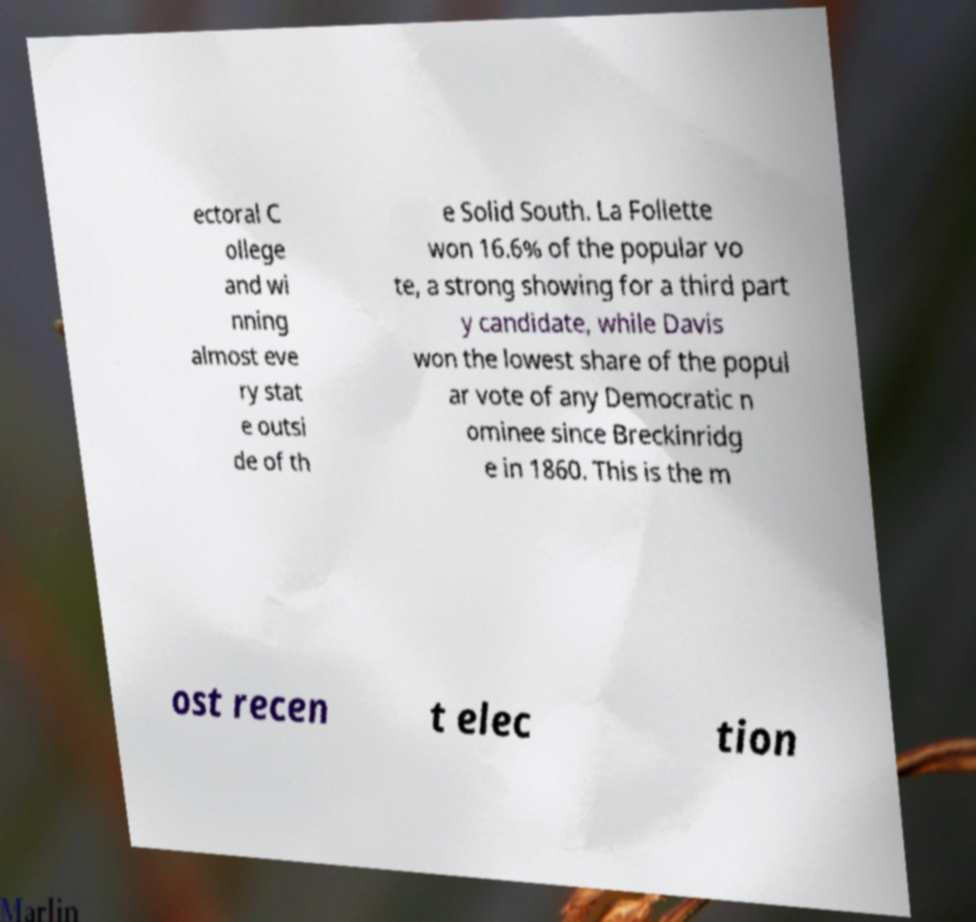Please read and relay the text visible in this image. What does it say? ectoral C ollege and wi nning almost eve ry stat e outsi de of th e Solid South. La Follette won 16.6% of the popular vo te, a strong showing for a third part y candidate, while Davis won the lowest share of the popul ar vote of any Democratic n ominee since Breckinridg e in 1860. This is the m ost recen t elec tion 